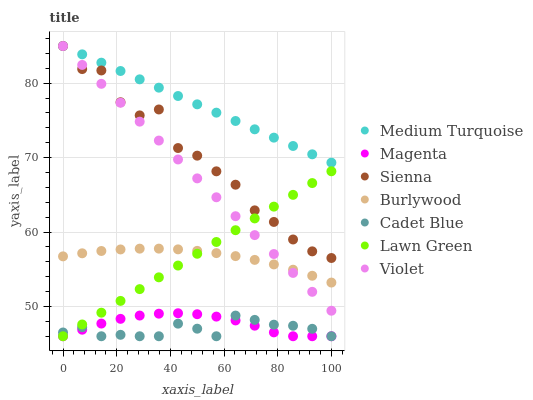Does Cadet Blue have the minimum area under the curve?
Answer yes or no. Yes. Does Medium Turquoise have the maximum area under the curve?
Answer yes or no. Yes. Does Burlywood have the minimum area under the curve?
Answer yes or no. No. Does Burlywood have the maximum area under the curve?
Answer yes or no. No. Is Lawn Green the smoothest?
Answer yes or no. Yes. Is Sienna the roughest?
Answer yes or no. Yes. Is Cadet Blue the smoothest?
Answer yes or no. No. Is Cadet Blue the roughest?
Answer yes or no. No. Does Lawn Green have the lowest value?
Answer yes or no. Yes. Does Burlywood have the lowest value?
Answer yes or no. No. Does Violet have the highest value?
Answer yes or no. Yes. Does Burlywood have the highest value?
Answer yes or no. No. Is Magenta less than Violet?
Answer yes or no. Yes. Is Medium Turquoise greater than Burlywood?
Answer yes or no. Yes. Does Cadet Blue intersect Lawn Green?
Answer yes or no. Yes. Is Cadet Blue less than Lawn Green?
Answer yes or no. No. Is Cadet Blue greater than Lawn Green?
Answer yes or no. No. Does Magenta intersect Violet?
Answer yes or no. No. 